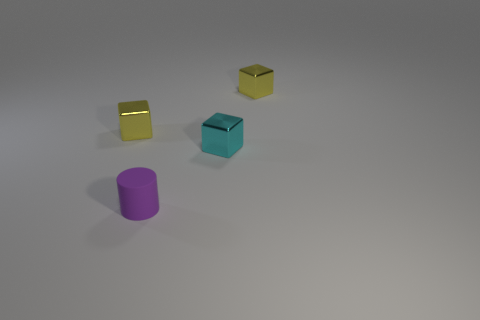Can you tell me about the lightning and shadows in the scene? The scene is lit from the upper right-hand side, as indicated by the shadows cast diagonally to the lower left side of each object. The lighting seems to be soft and diffused, resulting in soft-edged shadows, which contribute to the overall tranquil and minimalist aesthetic of the image. 